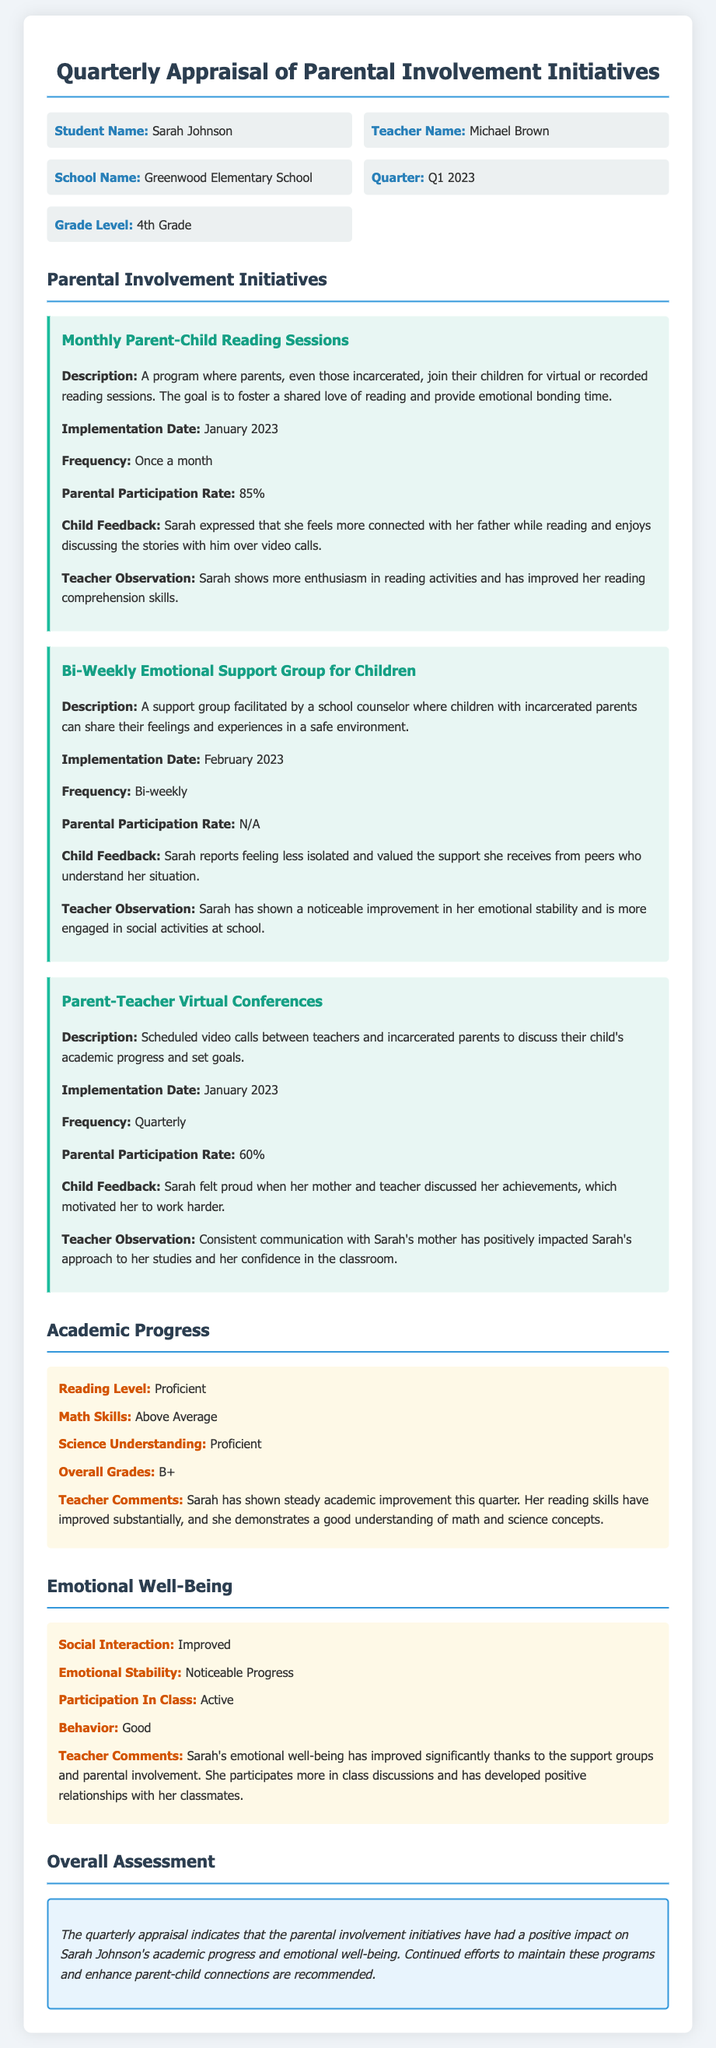What is the student's name? The student's name is explicitly stated in the document under "Student Name."
Answer: Sarah Johnson What is the frequency of the Monthly Parent-Child Reading Sessions? The frequency of the sessions is detailed under the initiative description.
Answer: Once a month What is the parental participation rate for the Parent-Teacher Virtual Conferences? The participation rate is mentioned in the details of the initiative.
Answer: 60% When was the Bi-Weekly Emotional Support Group for Children implemented? The implementation date can be found in the initiative description section.
Answer: February 2023 How has Sarah's reading level been assessed? Sarah's reading level assessment is stated in the academic progress section of the document.
Answer: Proficient What improvement has Sarah shown in social interaction? The document highlights the improvements in Sarah's emotional well-being within a specified section.
Answer: Improved Which area did Sarah demonstrate above average skills? This information is included in the academic progress section, detailing her skills.
Answer: Math Skills What is the overall grade received by Sarah this quarter? The overall grade is explicitly mentioned in the academic progress section.
Answer: B+ What is the primary reason for the positive impact on Sarah's emotional well-being? The reason for this improvement is discussed in the teacher comments section.
Answer: Support groups and parental involvement 